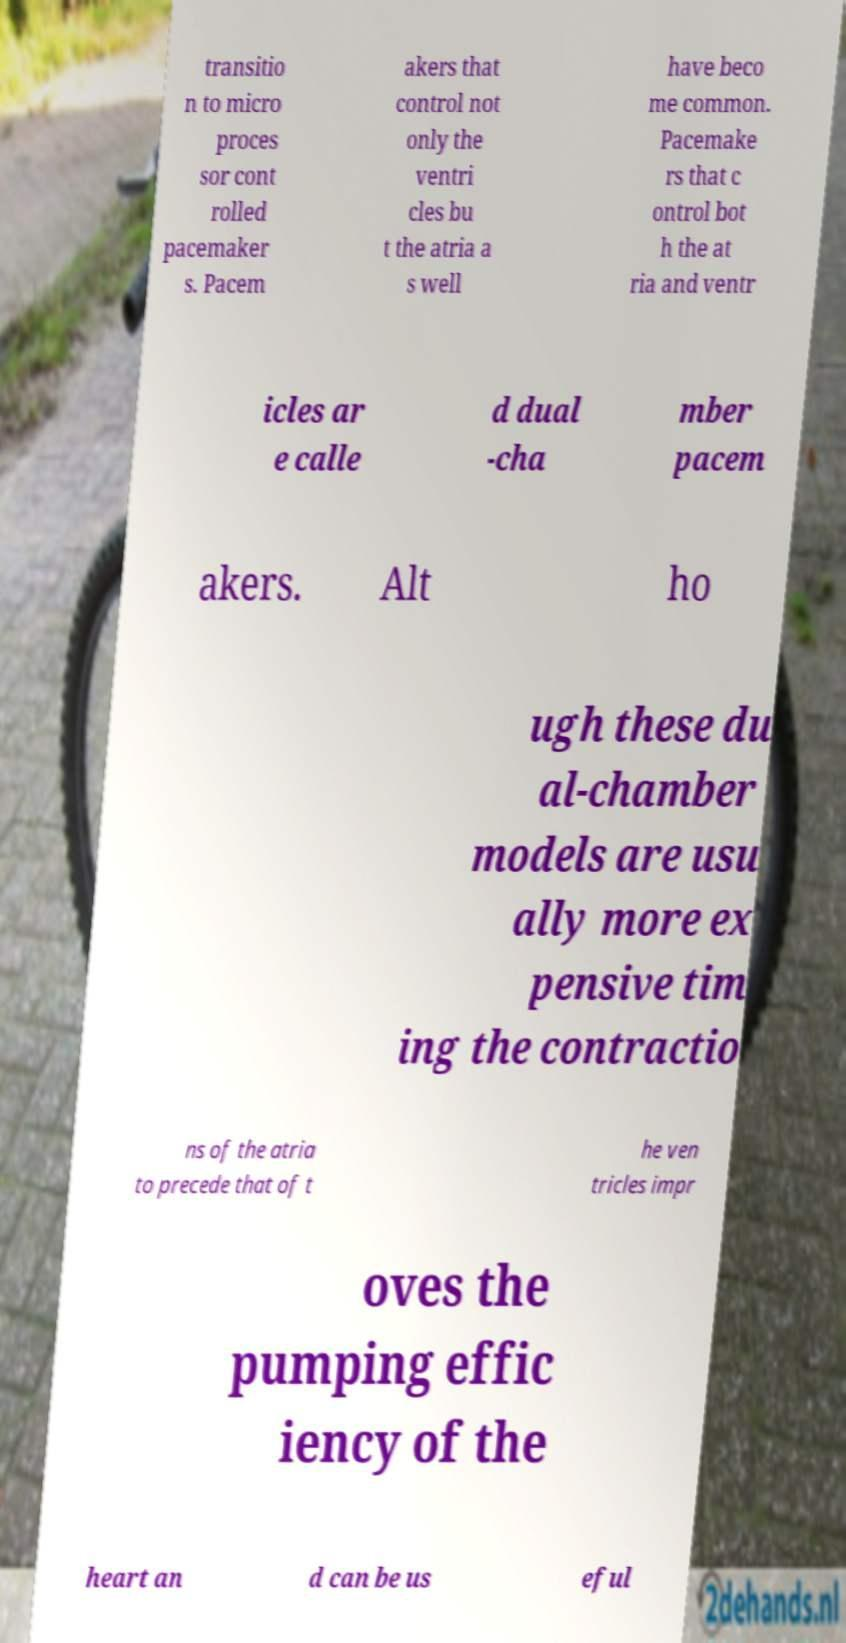What messages or text are displayed in this image? I need them in a readable, typed format. transitio n to micro proces sor cont rolled pacemaker s. Pacem akers that control not only the ventri cles bu t the atria a s well have beco me common. Pacemake rs that c ontrol bot h the at ria and ventr icles ar e calle d dual -cha mber pacem akers. Alt ho ugh these du al-chamber models are usu ally more ex pensive tim ing the contractio ns of the atria to precede that of t he ven tricles impr oves the pumping effic iency of the heart an d can be us eful 